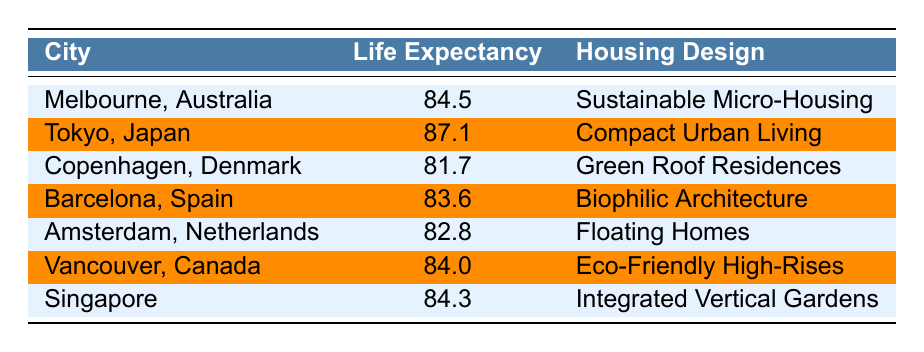What is the life expectancy in Tokyo, Japan? According to the table, Tokyo, Japan has a life expectancy listed as 87.1 years.
Answer: 87.1 Which city has the lowest life expectancy? Upon examining the table, Copenhagen, Denmark has the lowest life expectancy at 81.7 years.
Answer: 81.7 What is the average life expectancy of the cities listed? The life expectancies of the cities are: 84.5, 87.1, 81.7, 83.6, 82.8, 84.0, and 84.3. Adding these values gives 508.0. There are 7 cities, so the average life expectancy is 508.0 / 7 = 72.57.
Answer: 72.57 Is the life expectancy in Vancouver higher than in Amsterdam? Vancouver has a life expectancy of 84.0 years, while Amsterdam has 82.8 years. Since 84.0 is greater than 82.8, the answer is yes.
Answer: Yes Which housing design corresponds to the city with the highest life expectancy? Tokyo, Japan has the highest life expectancy at 87.1 years, and its corresponding housing design is Compact Urban Living.
Answer: Compact Urban Living What is the difference in life expectancy between Melbourne and Sydney? The table does not provide data on Sydney; therefore, we cannot determine a difference. So, the answer is not applicable.
Answer: Not applicable Does Barcelona have a higher life expectancy than Copenhagen? Barcelona has a life expectancy of 83.6 years, while Copenhagen has 81.7 years. Since 83.6 is greater than 81.7, this statement is true.
Answer: Yes Which city has a life expectancy of 84.3, and what is its housing design? The city with a life expectancy of 84.3 years is Singapore, and the housing design listed for it is Integrated Vertical Gardens.
Answer: Integrated Vertical Gardens What is the total life expectancy of all the cities listed? Summing the life expectancies: 84.5 + 87.1 + 81.7 + 83.6 + 82.8 + 84.0 + 84.3 = 508.0. This is the total life expectancy for these cities.
Answer: 508.0 